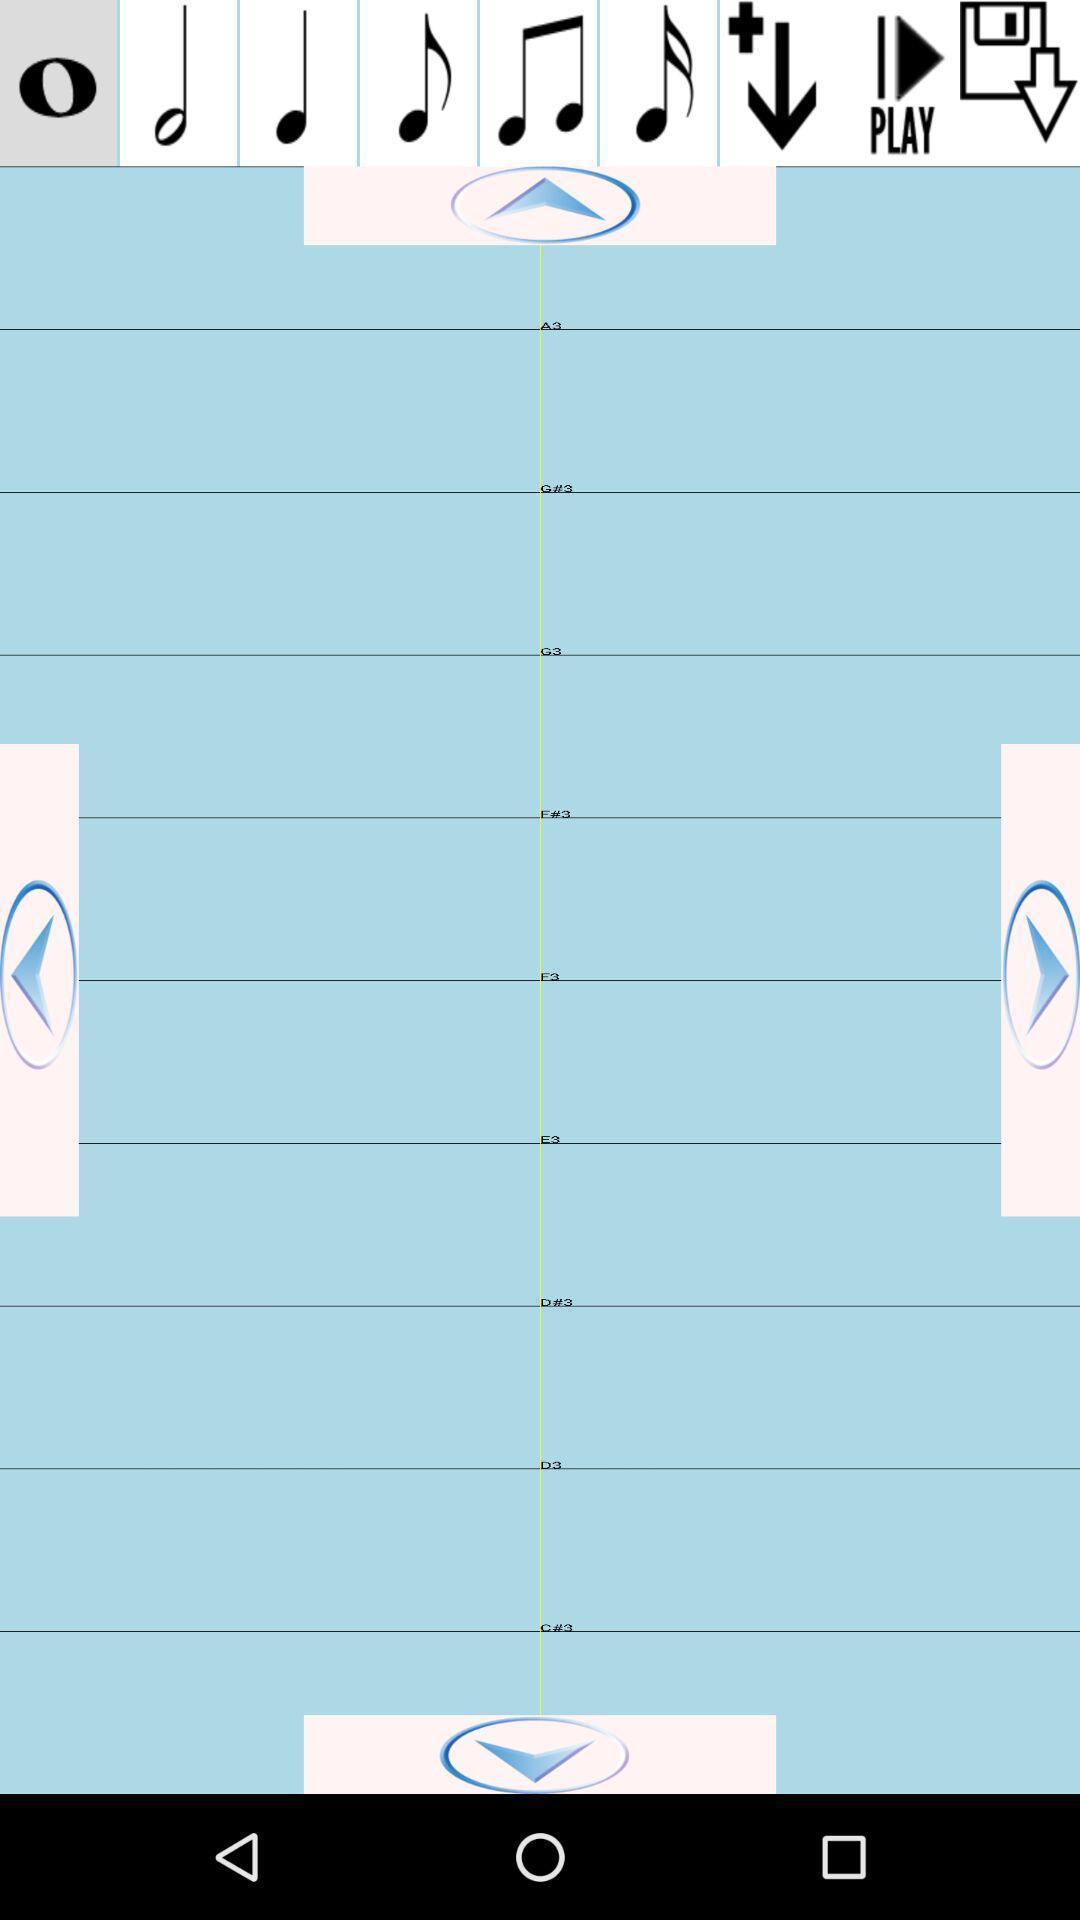Summarize the information in this screenshot. Screen showing various controls of a music player app. 